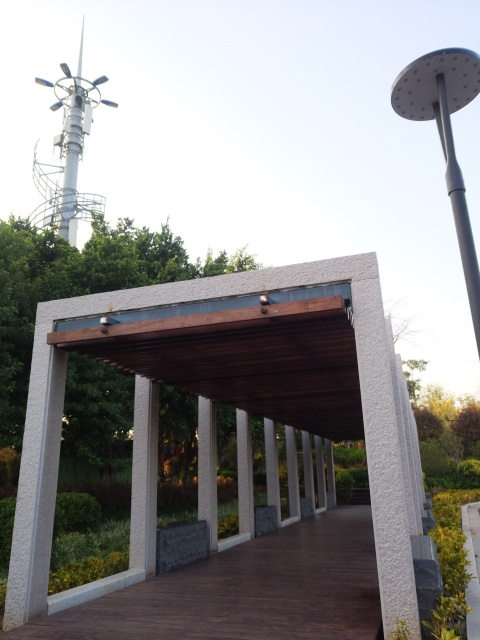Does the photo have high contrast?
A. No
B. Yes
Answer with the option's letter from the given choices directly.
 B. 